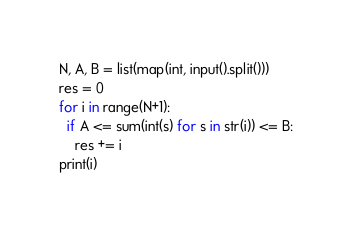<code> <loc_0><loc_0><loc_500><loc_500><_Python_>N, A, B = list(map(int, input().split()))
res = 0
for i in range(N+1):
  if A <= sum(int(s) for s in str(i)) <= B:
    res += i
print(i)</code> 